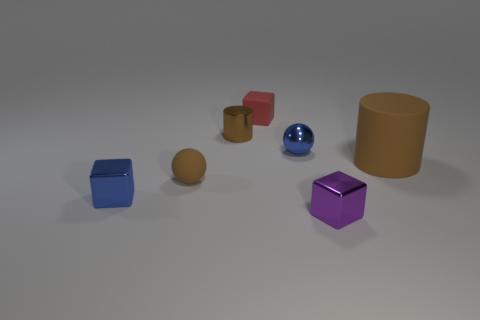Add 2 red rubber objects. How many objects exist? 9 Subtract all spheres. How many objects are left? 5 Subtract all big purple matte balls. Subtract all red rubber objects. How many objects are left? 6 Add 7 tiny red objects. How many tiny red objects are left? 8 Add 1 brown cubes. How many brown cubes exist? 1 Subtract 1 brown spheres. How many objects are left? 6 